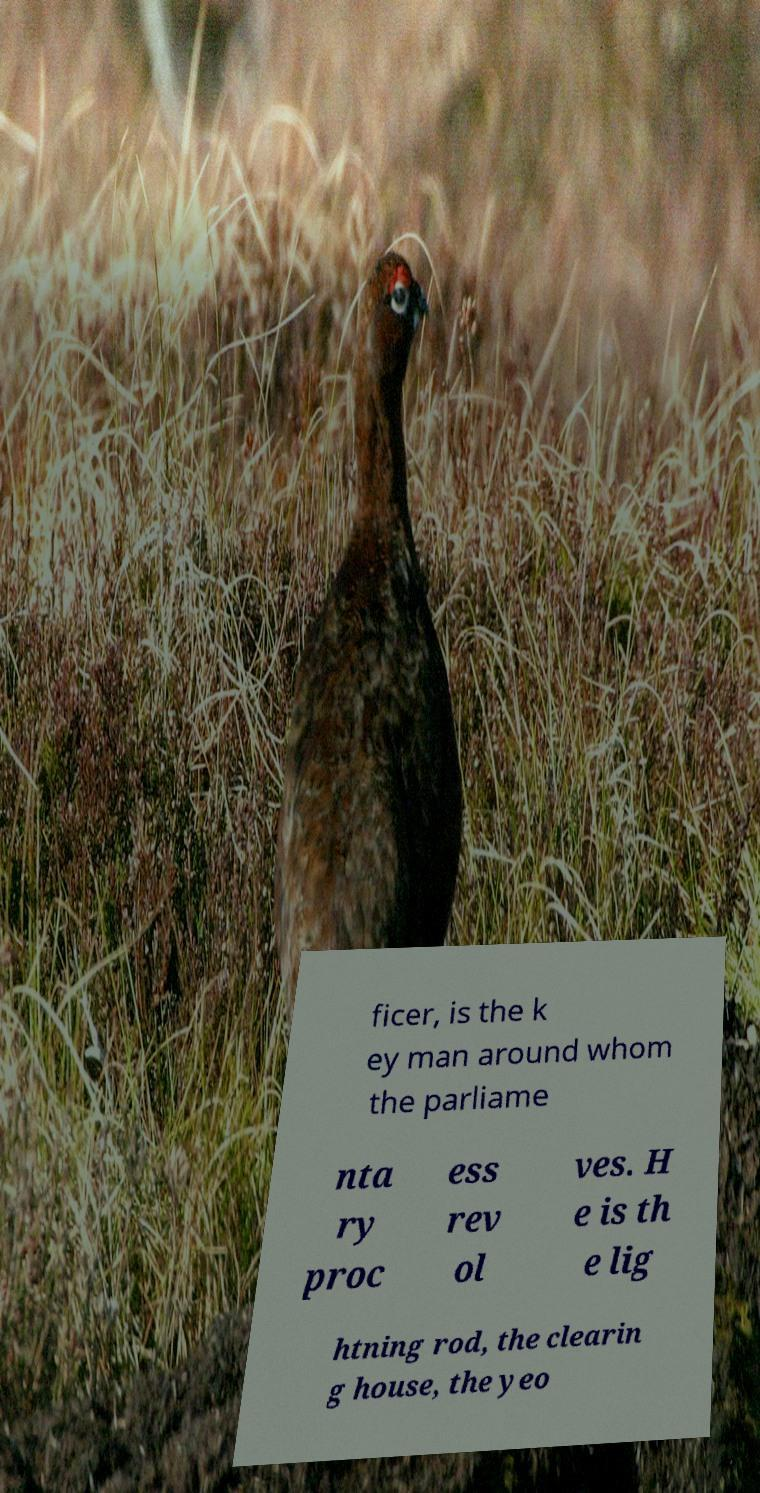Can you accurately transcribe the text from the provided image for me? ficer, is the k ey man around whom the parliame nta ry proc ess rev ol ves. H e is th e lig htning rod, the clearin g house, the yeo 